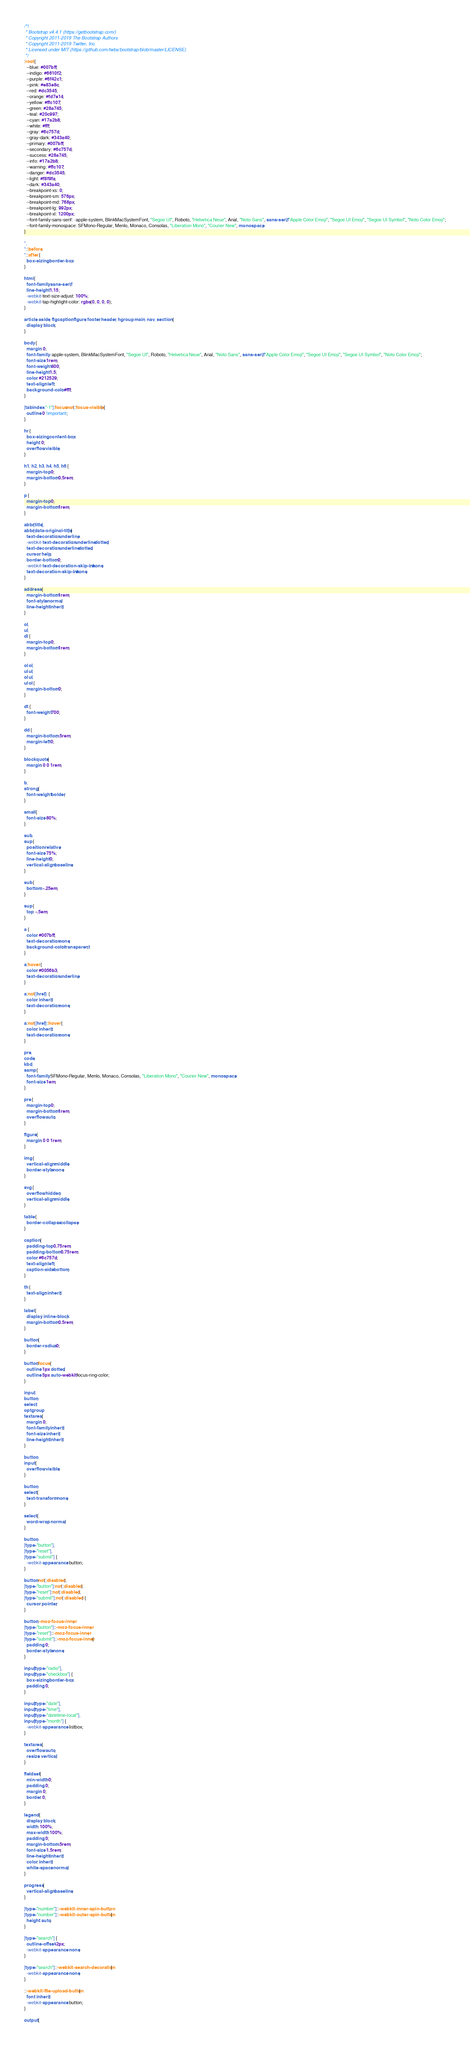<code> <loc_0><loc_0><loc_500><loc_500><_CSS_>/*!
 * Bootstrap v4.4.1 (https://getbootstrap.com/)
 * Copyright 2011-2019 The Bootstrap Authors
 * Copyright 2011-2019 Twitter, Inc.
 * Licensed under MIT (https://github.com/twbs/bootstrap/blob/master/LICENSE)
 */
:root {
  --blue: #007bff;
  --indigo: #6610f2;
  --purple: #6f42c1;
  --pink: #e83e8c;
  --red: #dc3545;
  --orange: #fd7e14;
  --yellow: #ffc107;
  --green: #28a745;
  --teal: #20c997;
  --cyan: #17a2b8;
  --white: #fff;
  --gray: #6c757d;
  --gray-dark: #343a40;
  --primary: #007bff;
  --secondary: #6c757d;
  --success: #28a745;
  --info: #17a2b8;
  --warning: #ffc107;
  --danger: #dc3545;
  --light: #f8f9fa;
  --dark: #343a40;
  --breakpoint-xs: 0;
  --breakpoint-sm: 576px;
  --breakpoint-md: 768px;
  --breakpoint-lg: 992px;
  --breakpoint-xl: 1200px;
  --font-family-sans-serif: -apple-system, BlinkMacSystemFont, "Segoe UI", Roboto, "Helvetica Neue", Arial, "Noto Sans", sans-serif, "Apple Color Emoji", "Segoe UI Emoji", "Segoe UI Symbol", "Noto Color Emoji";
  --font-family-monospace: SFMono-Regular, Menlo, Monaco, Consolas, "Liberation Mono", "Courier New", monospace;
}

*,
*::before,
*::after {
  box-sizing: border-box;
}

html {
  font-family: sans-serif;
  line-height: 1.15;
  -webkit-text-size-adjust: 100%;
  -webkit-tap-highlight-color: rgba(0, 0, 0, 0);
}

article, aside, figcaption, figure, footer, header, hgroup, main, nav, section {
  display: block;
}

body {
  margin: 0;
  font-family: -apple-system, BlinkMacSystemFont, "Segoe UI", Roboto, "Helvetica Neue", Arial, "Noto Sans", sans-serif, "Apple Color Emoji", "Segoe UI Emoji", "Segoe UI Symbol", "Noto Color Emoji";
  font-size: 1rem;
  font-weight: 400;
  line-height: 1.5;
  color: #212529;
  text-align: left;
  background-color: #fff;
}

[tabindex="-1"]:focus:not(:focus-visible) {
  outline: 0 !important;
}

hr {
  box-sizing: content-box;
  height: 0;
  overflow: visible;
}

h1, h2, h3, h4, h5, h6 {
  margin-top: 0;
  margin-bottom: 0.5rem;
}

p {
  margin-top: 0;
  margin-bottom: 1rem;
}

abbr[title],
abbr[data-original-title] {
  text-decoration: underline;
  -webkit-text-decoration: underline dotted;
  text-decoration: underline dotted;
  cursor: help;
  border-bottom: 0;
  -webkit-text-decoration-skip-ink: none;
  text-decoration-skip-ink: none;
}

address {
  margin-bottom: 1rem;
  font-style: normal;
  line-height: inherit;
}

ol,
ul,
dl {
  margin-top: 0;
  margin-bottom: 1rem;
}

ol ol,
ul ul,
ol ul,
ul ol {
  margin-bottom: 0;
}

dt {
  font-weight: 700;
}

dd {
  margin-bottom: .5rem;
  margin-left: 0;
}

blockquote {
  margin: 0 0 1rem;
}

b,
strong {
  font-weight: bolder;
}

small {
  font-size: 80%;
}

sub,
sup {
  position: relative;
  font-size: 75%;
  line-height: 0;
  vertical-align: baseline;
}

sub {
  bottom: -.25em;
}

sup {
  top: -.5em;
}

a {
  color: #007bff;
  text-decoration: none;
  background-color: transparent;
}

a:hover {
  color: #0056b3;
  text-decoration: underline;
}

a:not([href]) {
  color: inherit;
  text-decoration: none;
}

a:not([href]):hover {
  color: inherit;
  text-decoration: none;
}

pre,
code,
kbd,
samp {
  font-family: SFMono-Regular, Menlo, Monaco, Consolas, "Liberation Mono", "Courier New", monospace;
  font-size: 1em;
}

pre {
  margin-top: 0;
  margin-bottom: 1rem;
  overflow: auto;
}

figure {
  margin: 0 0 1rem;
}

img {
  vertical-align: middle;
  border-style: none;
}

svg {
  overflow: hidden;
  vertical-align: middle;
}

table {
  border-collapse: collapse;
}

caption {
  padding-top: 0.75rem;
  padding-bottom: 0.75rem;
  color: #6c757d;
  text-align: left;
  caption-side: bottom;
}

th {
  text-align: inherit;
}

label {
  display: inline-block;
  margin-bottom: 0.5rem;
}

button {
  border-radius: 0;
}

button:focus {
  outline: 1px dotted;
  outline: 5px auto -webkit-focus-ring-color;
}

input,
button,
select,
optgroup,
textarea {
  margin: 0;
  font-family: inherit;
  font-size: inherit;
  line-height: inherit;
}

button,
input {
  overflow: visible;
}

button,
select {
  text-transform: none;
}

select {
  word-wrap: normal;
}

button,
[type="button"],
[type="reset"],
[type="submit"] {
  -webkit-appearance: button;
}

button:not(:disabled),
[type="button"]:not(:disabled),
[type="reset"]:not(:disabled),
[type="submit"]:not(:disabled) {
  cursor: pointer;
}

button::-moz-focus-inner,
[type="button"]::-moz-focus-inner,
[type="reset"]::-moz-focus-inner,
[type="submit"]::-moz-focus-inner {
  padding: 0;
  border-style: none;
}

input[type="radio"],
input[type="checkbox"] {
  box-sizing: border-box;
  padding: 0;
}

input[type="date"],
input[type="time"],
input[type="datetime-local"],
input[type="month"] {
  -webkit-appearance: listbox;
}

textarea {
  overflow: auto;
  resize: vertical;
}

fieldset {
  min-width: 0;
  padding: 0;
  margin: 0;
  border: 0;
}

legend {
  display: block;
  width: 100%;
  max-width: 100%;
  padding: 0;
  margin-bottom: .5rem;
  font-size: 1.5rem;
  line-height: inherit;
  color: inherit;
  white-space: normal;
}

progress {
  vertical-align: baseline;
}

[type="number"]::-webkit-inner-spin-button,
[type="number"]::-webkit-outer-spin-button {
  height: auto;
}

[type="search"] {
  outline-offset: -2px;
  -webkit-appearance: none;
}

[type="search"]::-webkit-search-decoration {
  -webkit-appearance: none;
}

::-webkit-file-upload-button {
  font: inherit;
  -webkit-appearance: button;
}

output {</code> 